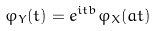<formula> <loc_0><loc_0><loc_500><loc_500>\varphi _ { Y } ( t ) = e ^ { i t b } \varphi _ { X } ( a t )</formula> 